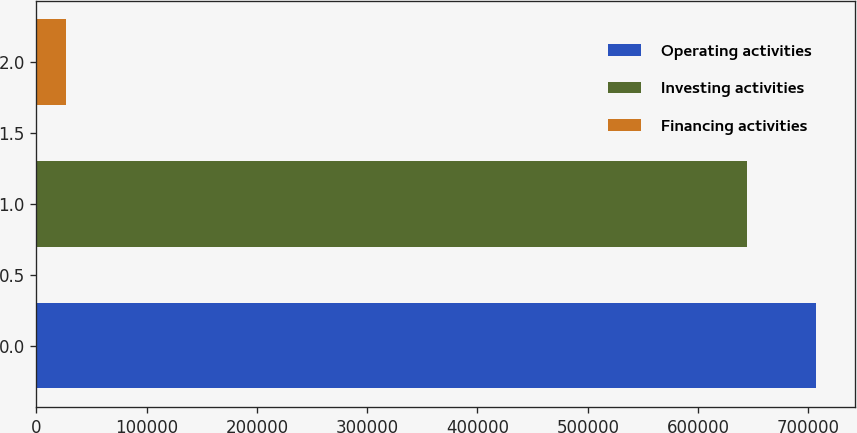Convert chart. <chart><loc_0><loc_0><loc_500><loc_500><bar_chart><fcel>Operating activities<fcel>Investing activities<fcel>Financing activities<nl><fcel>707071<fcel>644180<fcel>26974<nl></chart> 